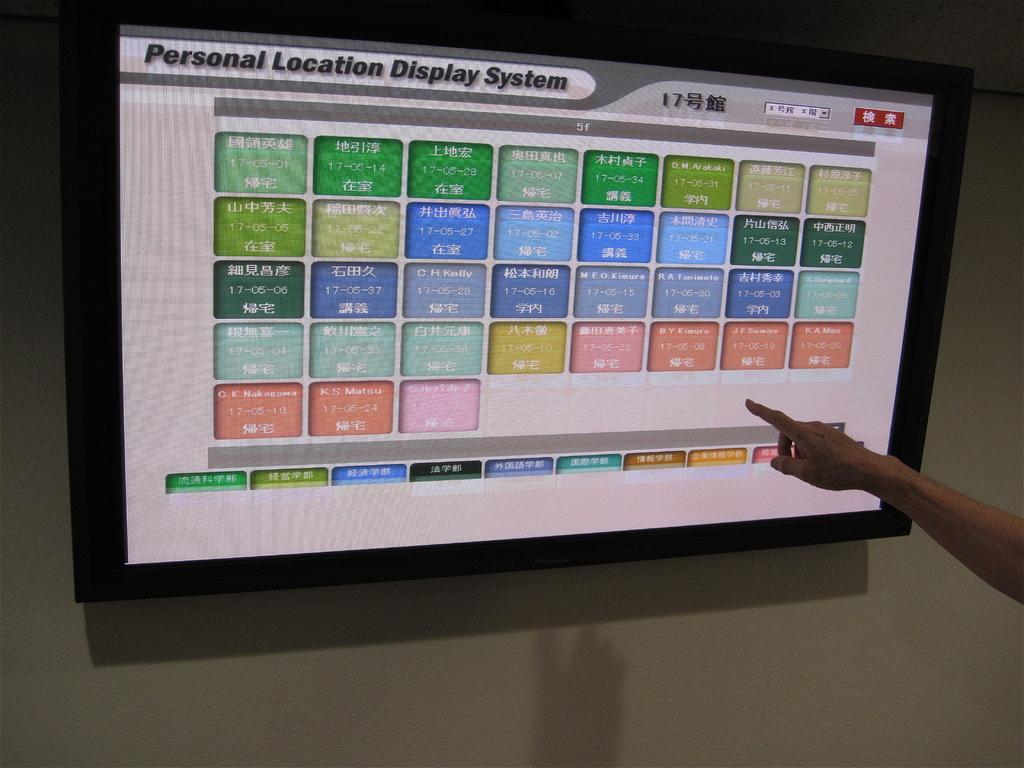What kind of program system is this?
Ensure brevity in your answer.  Personal location display system. 